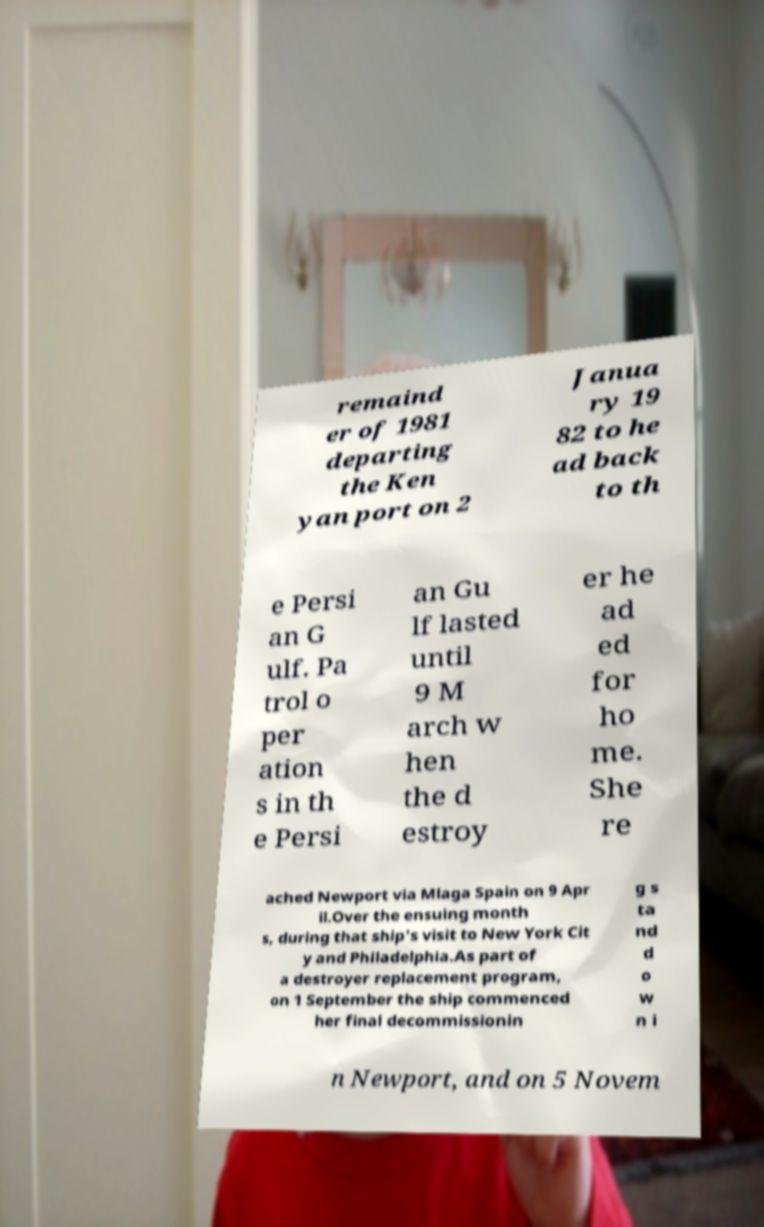For documentation purposes, I need the text within this image transcribed. Could you provide that? remaind er of 1981 departing the Ken yan port on 2 Janua ry 19 82 to he ad back to th e Persi an G ulf. Pa trol o per ation s in th e Persi an Gu lf lasted until 9 M arch w hen the d estroy er he ad ed for ho me. She re ached Newport via Mlaga Spain on 9 Apr il.Over the ensuing month s, during that ship's visit to New York Cit y and Philadelphia.As part of a destroyer replacement program, on 1 September the ship commenced her final decommissionin g s ta nd d o w n i n Newport, and on 5 Novem 